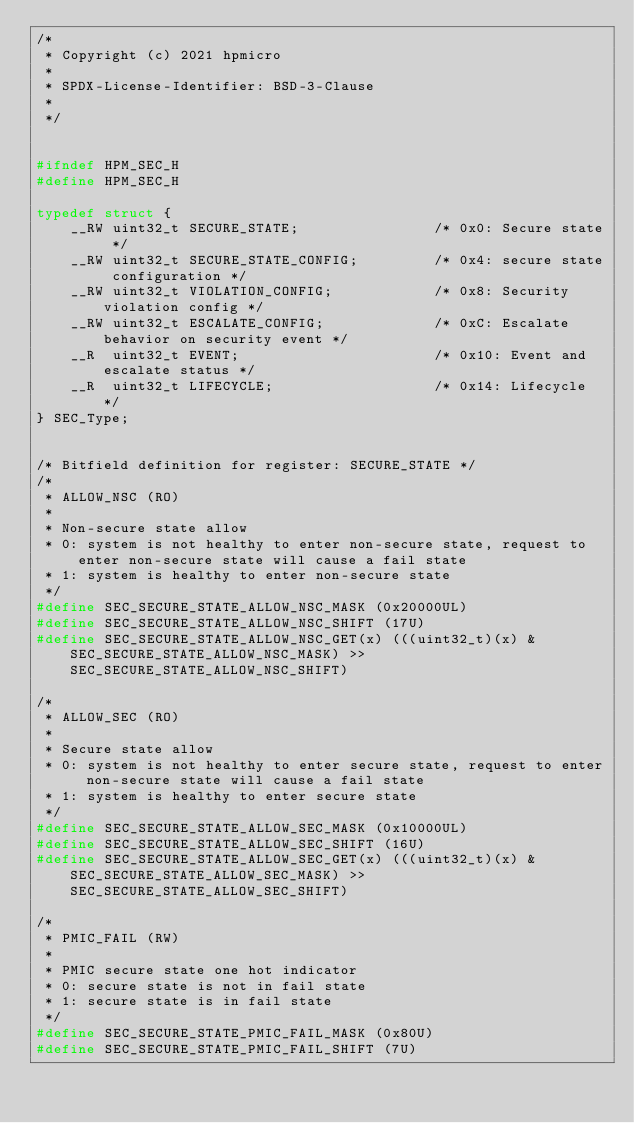<code> <loc_0><loc_0><loc_500><loc_500><_C_>/*
 * Copyright (c) 2021 hpmicro
 *
 * SPDX-License-Identifier: BSD-3-Clause
 *
 */


#ifndef HPM_SEC_H
#define HPM_SEC_H

typedef struct {
    __RW uint32_t SECURE_STATE;                /* 0x0: Secure state */
    __RW uint32_t SECURE_STATE_CONFIG;         /* 0x4: secure state configuration */
    __RW uint32_t VIOLATION_CONFIG;            /* 0x8: Security violation config */
    __RW uint32_t ESCALATE_CONFIG;             /* 0xC: Escalate behavior on security event */
    __R  uint32_t EVENT;                       /* 0x10: Event and escalate status */
    __R  uint32_t LIFECYCLE;                   /* 0x14: Lifecycle */
} SEC_Type;


/* Bitfield definition for register: SECURE_STATE */
/*
 * ALLOW_NSC (RO)
 *
 * Non-secure state allow
 * 0: system is not healthy to enter non-secure state, request to enter non-secure state will cause a fail state
 * 1: system is healthy to enter non-secure state
 */
#define SEC_SECURE_STATE_ALLOW_NSC_MASK (0x20000UL)
#define SEC_SECURE_STATE_ALLOW_NSC_SHIFT (17U)
#define SEC_SECURE_STATE_ALLOW_NSC_GET(x) (((uint32_t)(x) & SEC_SECURE_STATE_ALLOW_NSC_MASK) >> SEC_SECURE_STATE_ALLOW_NSC_SHIFT)

/*
 * ALLOW_SEC (RO)
 *
 * Secure state allow
 * 0: system is not healthy to enter secure state, request to enter non-secure state will cause a fail state
 * 1: system is healthy to enter secure state
 */
#define SEC_SECURE_STATE_ALLOW_SEC_MASK (0x10000UL)
#define SEC_SECURE_STATE_ALLOW_SEC_SHIFT (16U)
#define SEC_SECURE_STATE_ALLOW_SEC_GET(x) (((uint32_t)(x) & SEC_SECURE_STATE_ALLOW_SEC_MASK) >> SEC_SECURE_STATE_ALLOW_SEC_SHIFT)

/*
 * PMIC_FAIL (RW)
 *
 * PMIC secure state one hot indicator
 * 0: secure state is not in fail state
 * 1: secure state is in fail state
 */
#define SEC_SECURE_STATE_PMIC_FAIL_MASK (0x80U)
#define SEC_SECURE_STATE_PMIC_FAIL_SHIFT (7U)</code> 